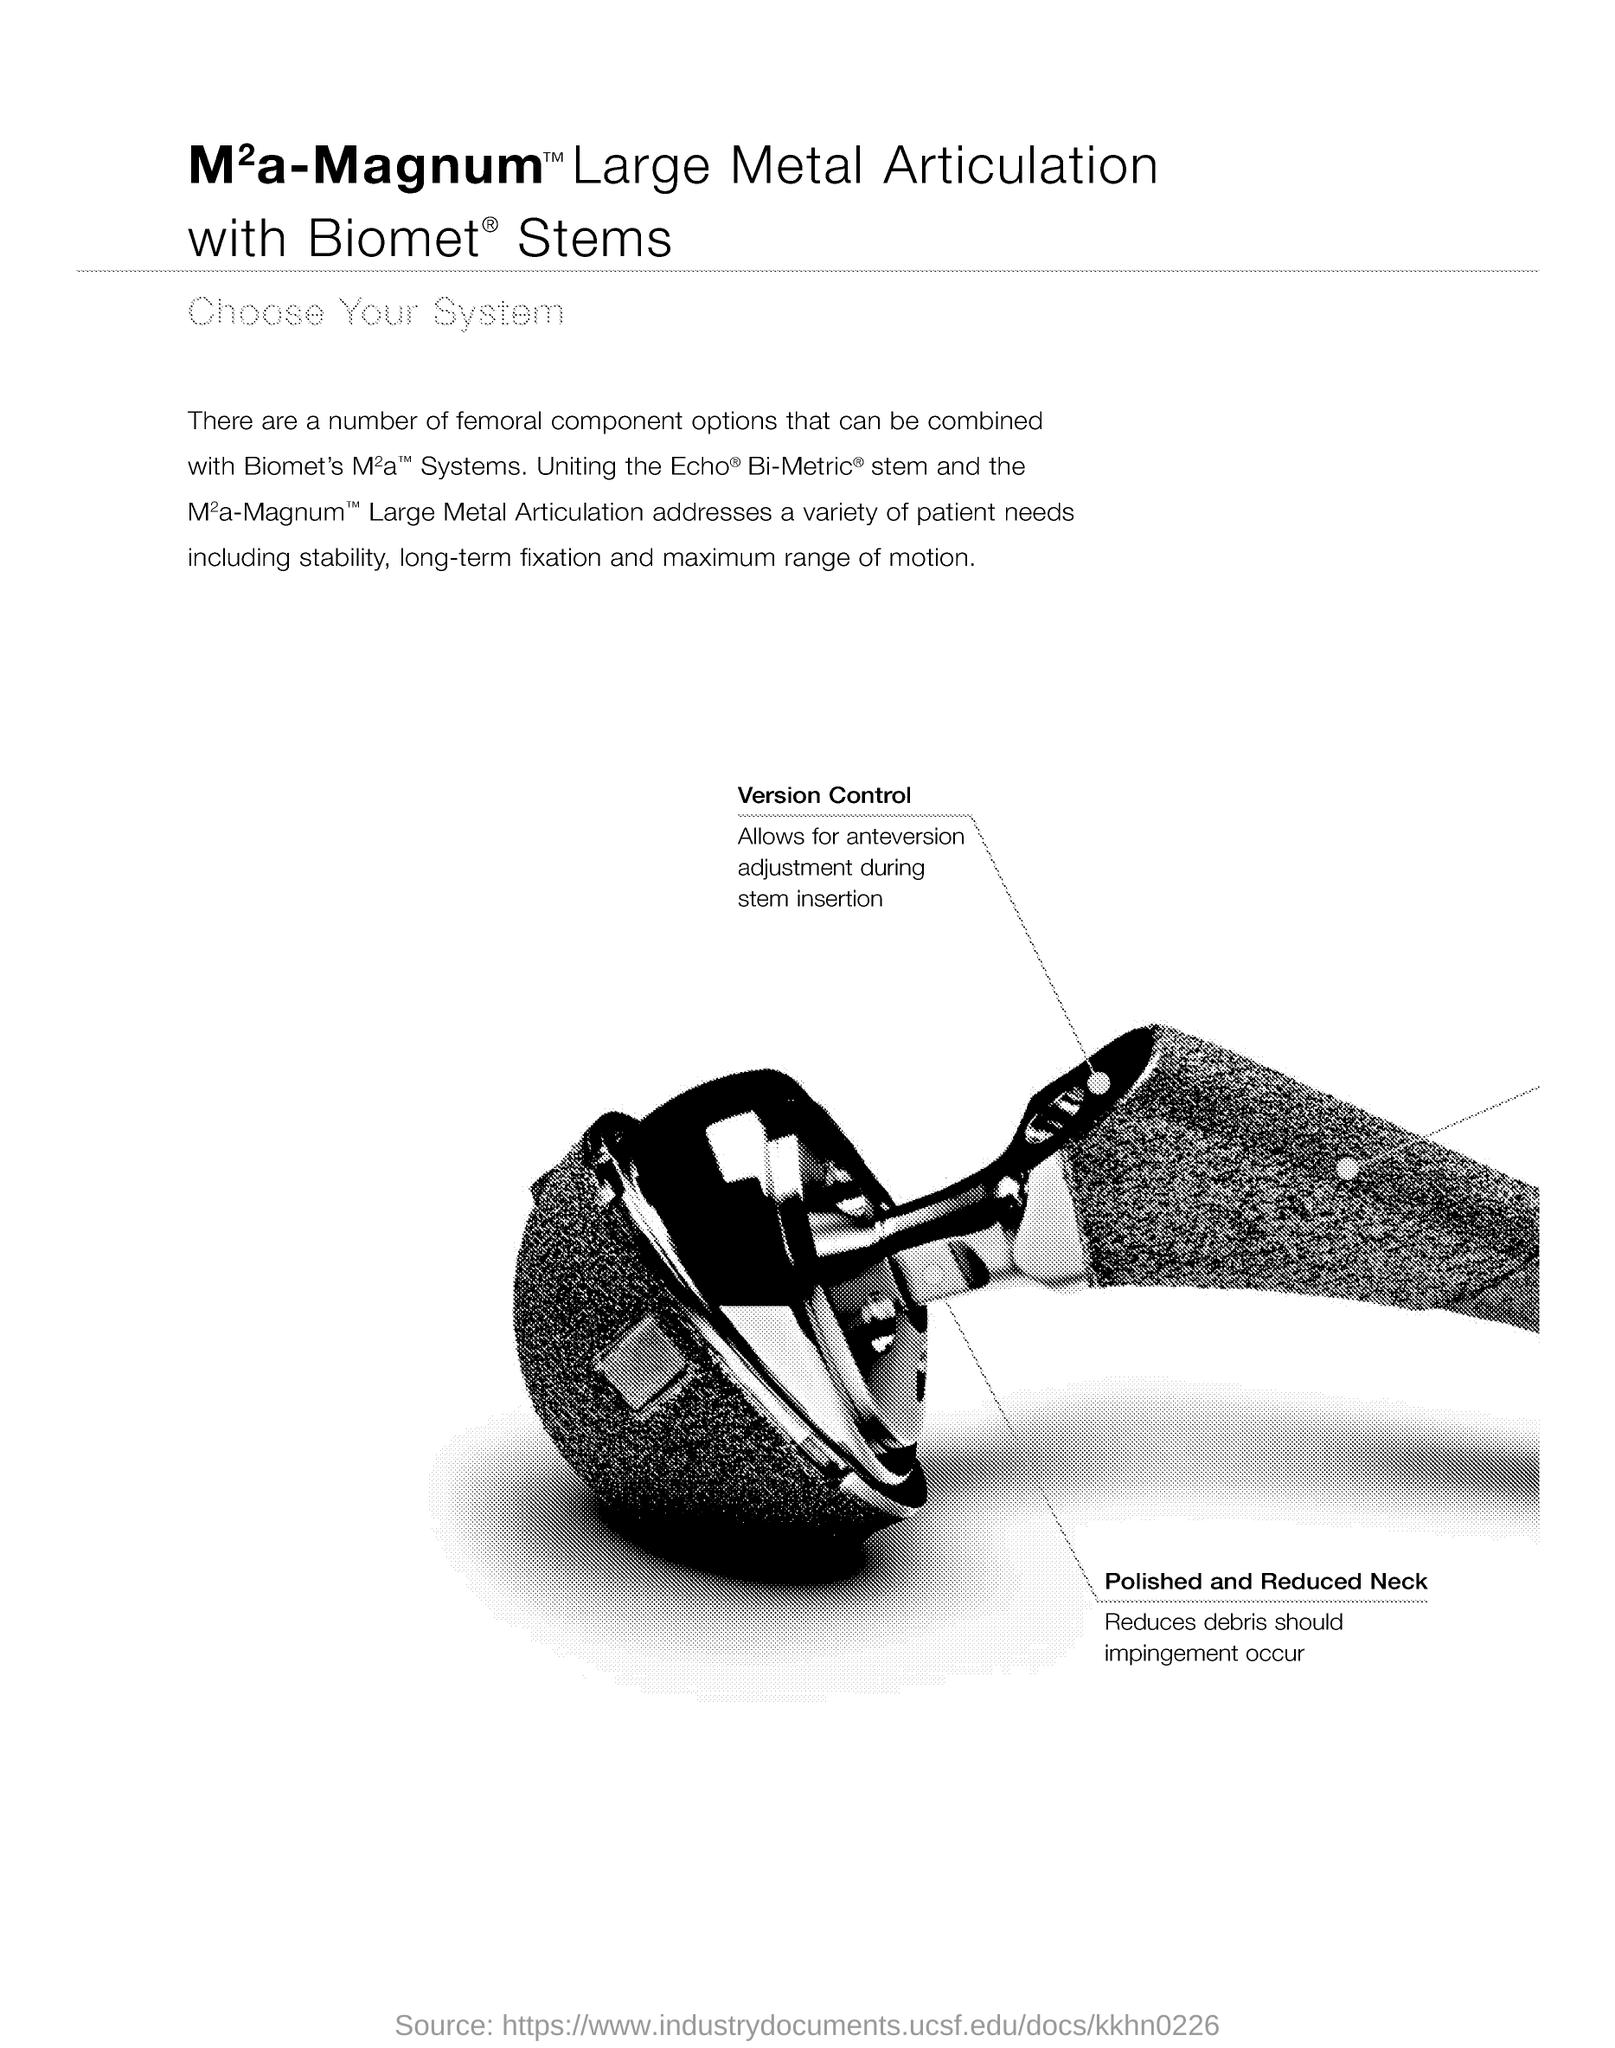What are the three things mentioned here that included in the variety of patient needs which the combination of femoral component specified in the document addresses?
Provide a short and direct response. Stability, long-term fixation and maximum range of motion. What is the purpose of polished and reduced neck?
Ensure brevity in your answer.  Reduces debris should impingement occur. What kind of neck reduces debris should impingement occur?
Your answer should be very brief. Polished and Reduced neck. What allows for anteversion adjustment during stem insertion?
Your response must be concise. Version Control. 